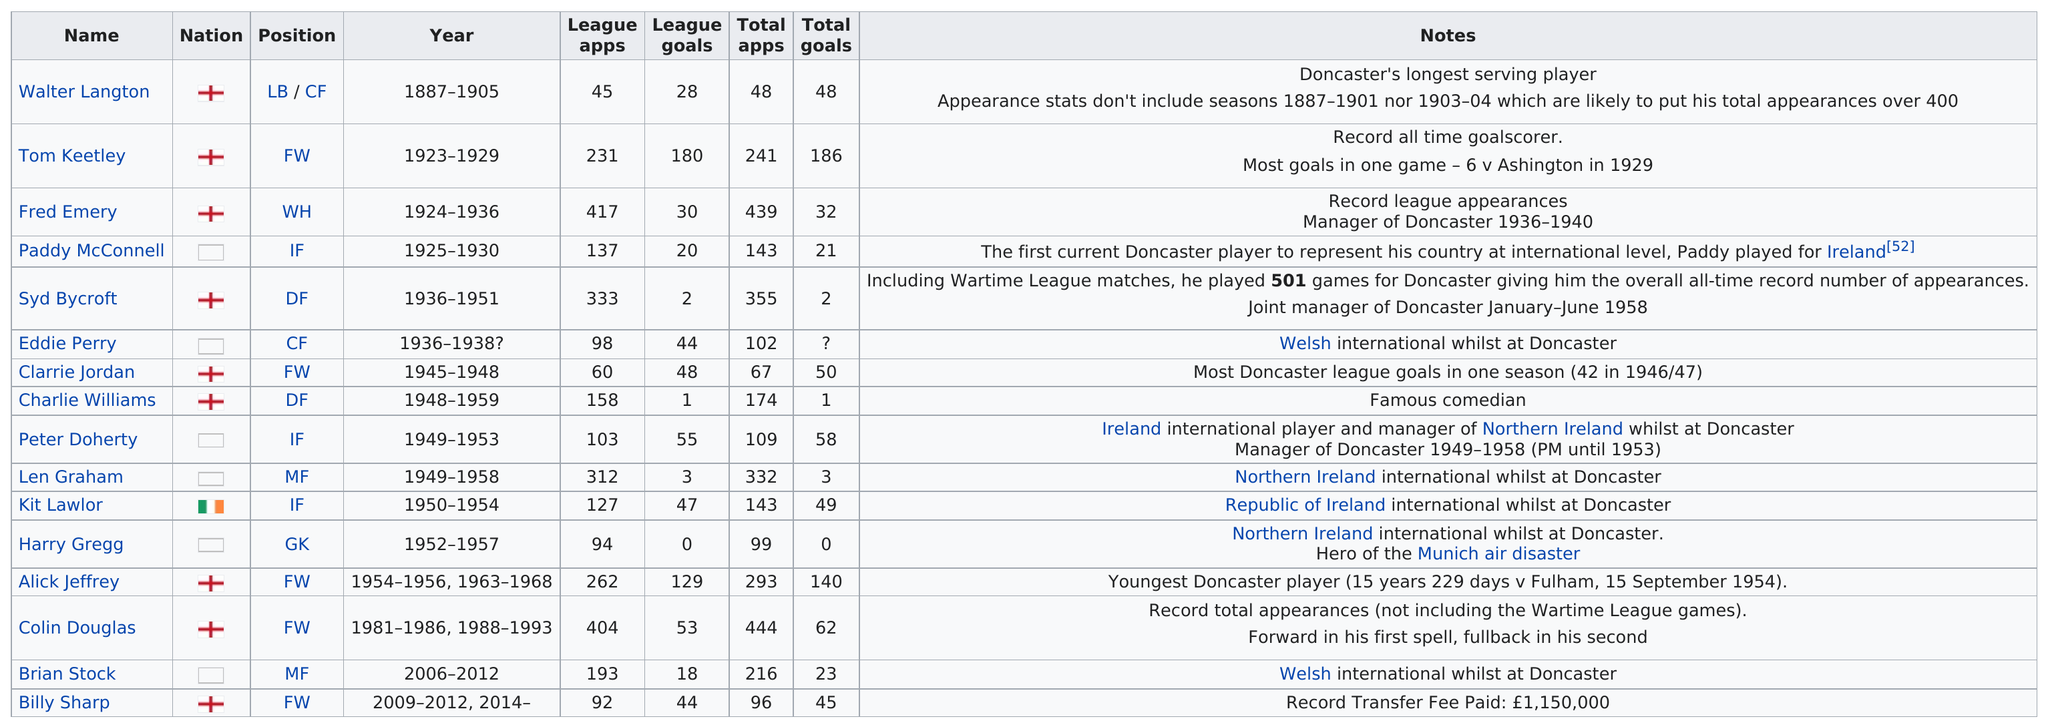Highlight a few significant elements in this photo. Syd Bycroft spent a total of 15 years playing for Doncaster. Billy Sharp, a renowned soccer player, scored a total of 44 league goals, cementing his place as a top scorer in the sport. Walter Langton's total number of goals is equal to his total number of appearances, making him one of the players with the highest goal-to-game ratio. Tom Keetley scored a record number of goals in one game, an impressive six goals. Kit Lawlor scored a total of 49 goals from 1950 to 1954. 